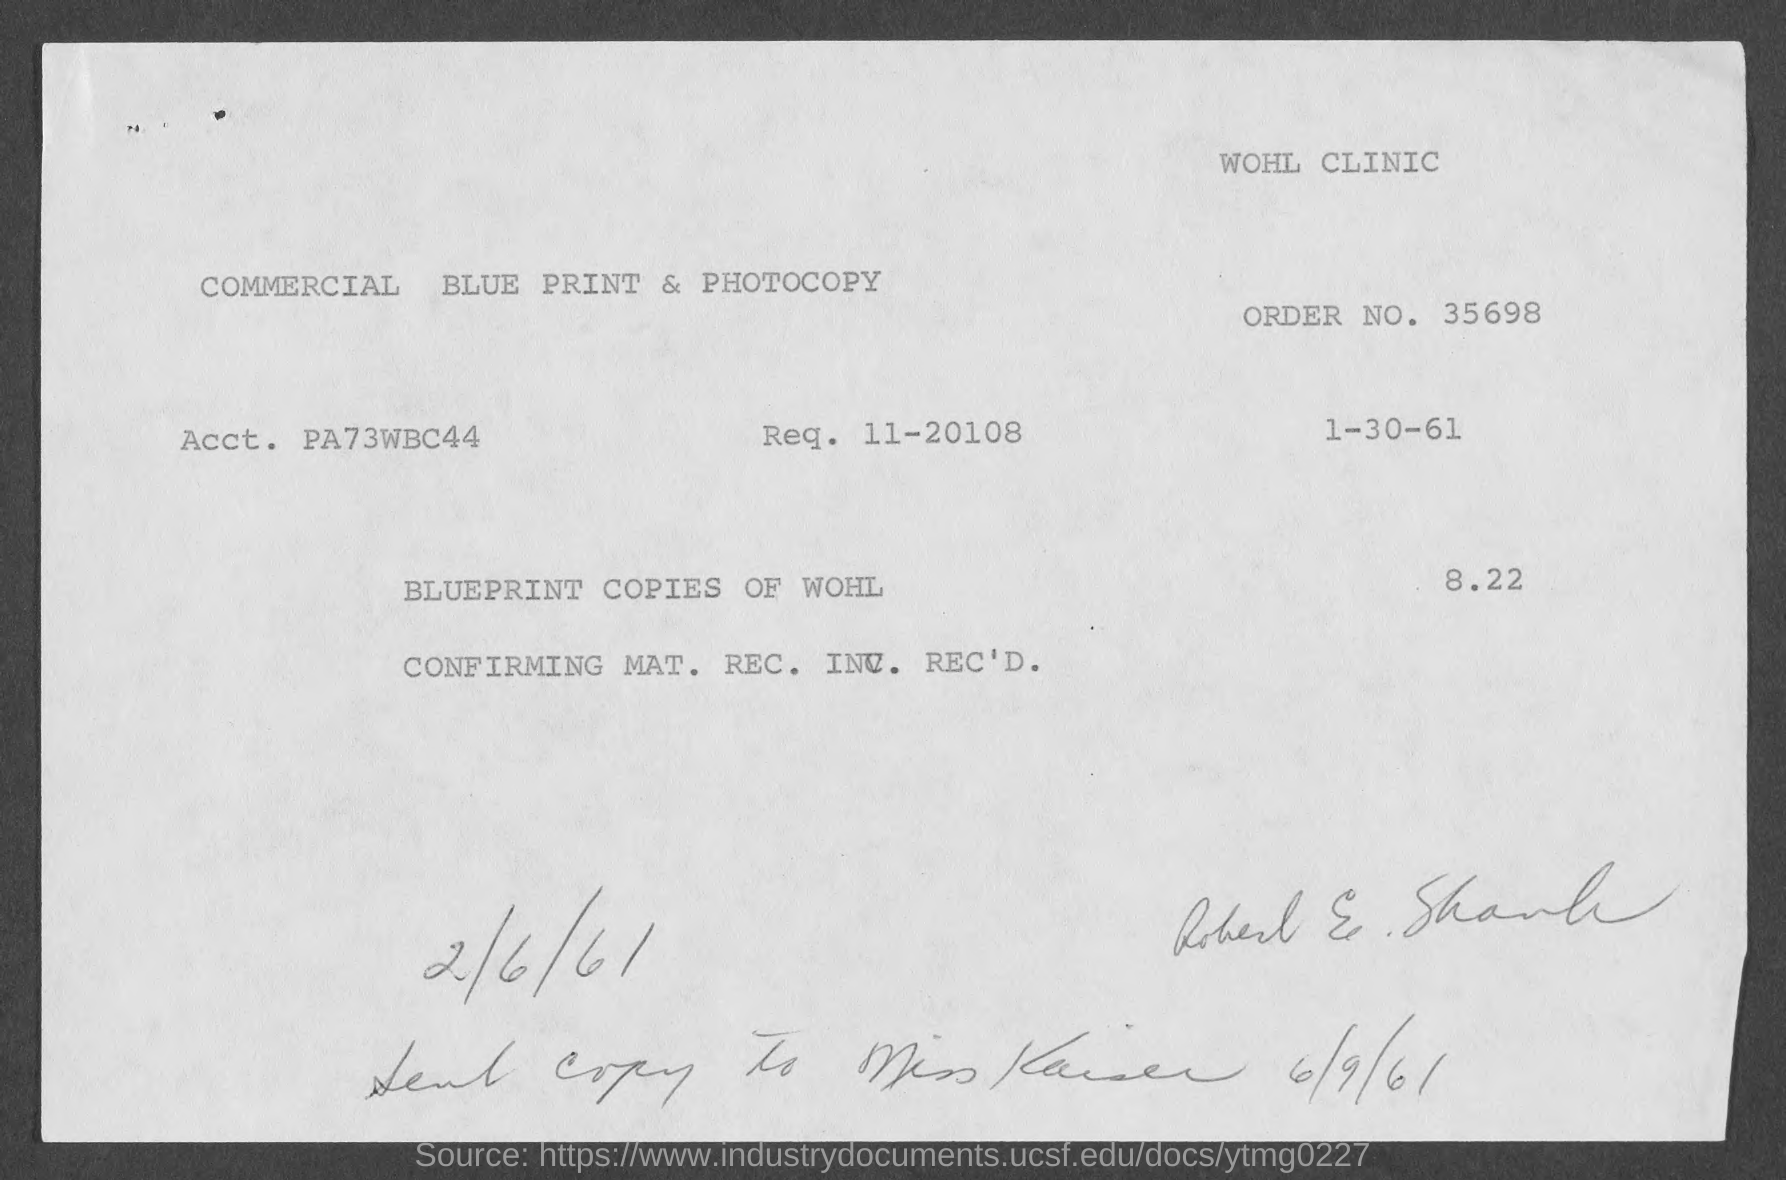Highlight a few significant elements in this photo. The order number is 35698... 